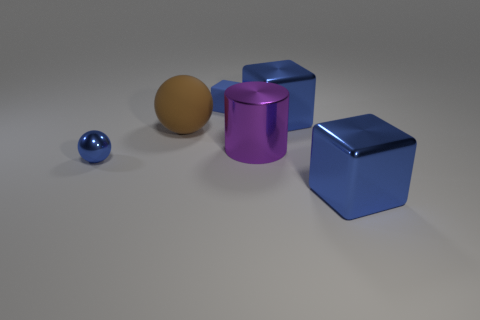Subtract all big blue cubes. How many cubes are left? 1 Subtract 2 balls. How many balls are left? 0 Subtract all brown balls. How many balls are left? 1 Add 1 small red matte cylinders. How many objects exist? 7 Subtract all gray cylinders. Subtract all purple cubes. How many cylinders are left? 1 Subtract all large brown objects. Subtract all big brown things. How many objects are left? 4 Add 2 small shiny things. How many small shiny things are left? 3 Add 1 cyan matte spheres. How many cyan matte spheres exist? 1 Subtract 0 yellow blocks. How many objects are left? 6 Subtract all spheres. How many objects are left? 4 